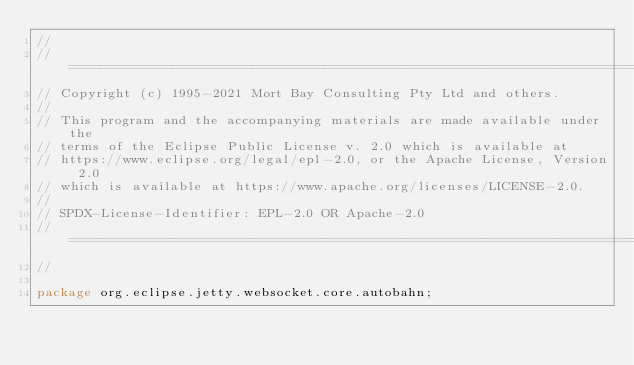Convert code to text. <code><loc_0><loc_0><loc_500><loc_500><_Java_>//
// ========================================================================
// Copyright (c) 1995-2021 Mort Bay Consulting Pty Ltd and others.
//
// This program and the accompanying materials are made available under the
// terms of the Eclipse Public License v. 2.0 which is available at
// https://www.eclipse.org/legal/epl-2.0, or the Apache License, Version 2.0
// which is available at https://www.apache.org/licenses/LICENSE-2.0.
//
// SPDX-License-Identifier: EPL-2.0 OR Apache-2.0
// ========================================================================
//

package org.eclipse.jetty.websocket.core.autobahn;
</code> 